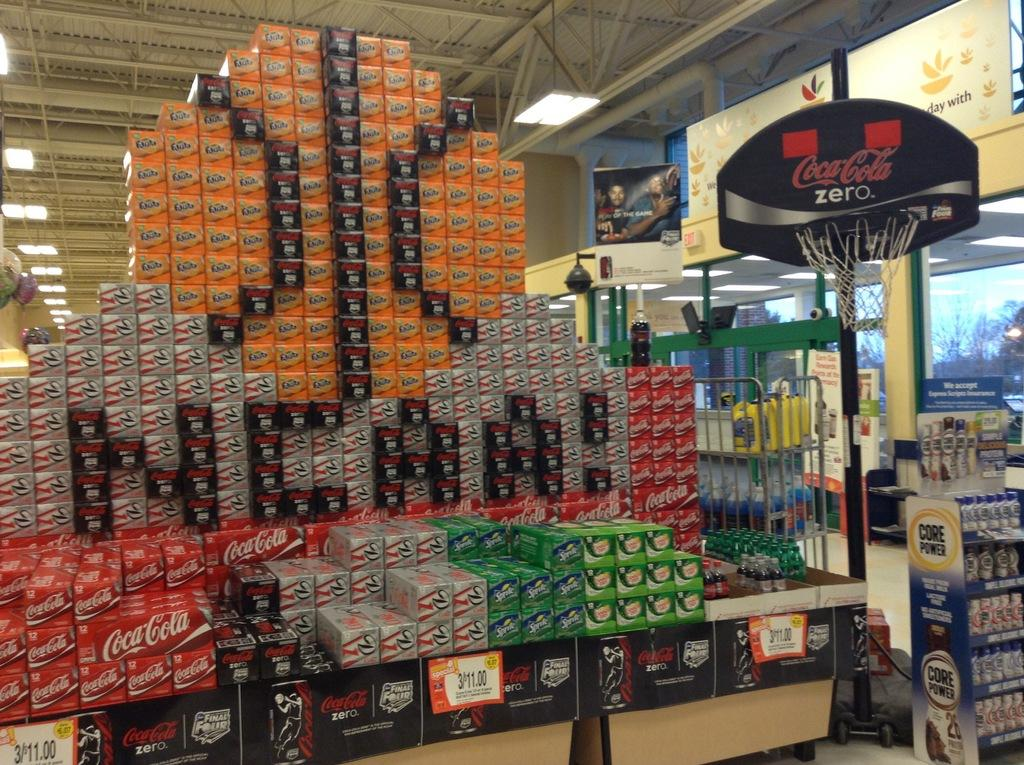Provide a one-sentence caption for the provided image. NCAA is displayed from soda boxes at this supermarket. 